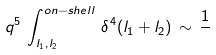Convert formula to latex. <formula><loc_0><loc_0><loc_500><loc_500>q ^ { 5 } \, \int _ { l _ { 1 } , l _ { 2 } } ^ { o n - s h e l l } \, \delta ^ { 4 } ( l _ { 1 } + l _ { 2 } ) \, \sim \, \frac { 1 } { }</formula> 